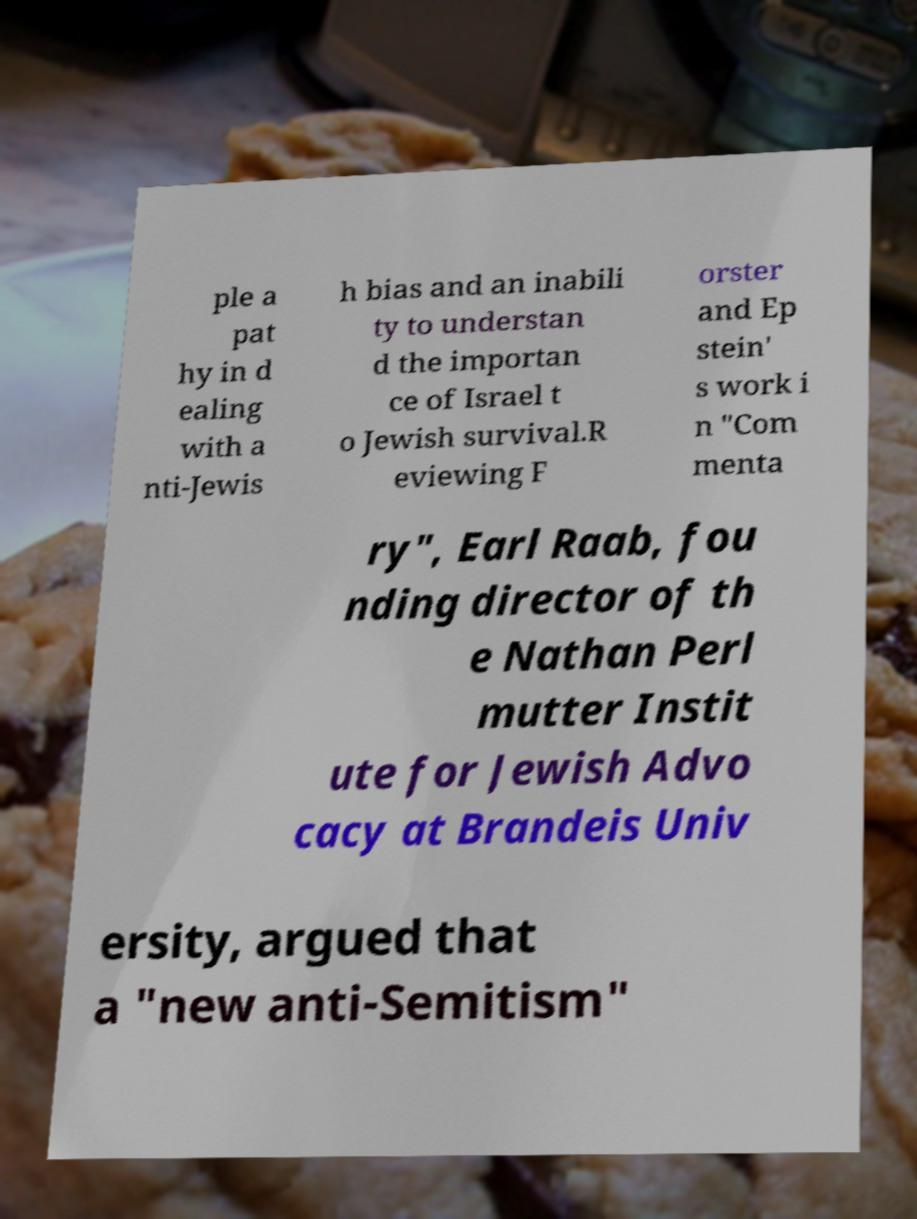Please read and relay the text visible in this image. What does it say? ple a pat hy in d ealing with a nti-Jewis h bias and an inabili ty to understan d the importan ce of Israel t o Jewish survival.R eviewing F orster and Ep stein' s work i n "Com menta ry", Earl Raab, fou nding director of th e Nathan Perl mutter Instit ute for Jewish Advo cacy at Brandeis Univ ersity, argued that a "new anti-Semitism" 